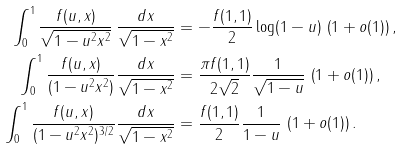Convert formula to latex. <formula><loc_0><loc_0><loc_500><loc_500>\int _ { 0 } ^ { 1 } \frac { f ( u , x ) } { \sqrt { 1 - u ^ { 2 } x ^ { 2 } } } \, \frac { d x } { \sqrt { 1 - x ^ { 2 } } } & = - \frac { f ( 1 , 1 ) } { 2 } \log ( 1 - u ) \, \left ( 1 + o ( 1 ) \right ) , \\ \int _ { 0 } ^ { 1 } \frac { f ( u , x ) } { ( 1 - u ^ { 2 } x ^ { 2 } ) } \frac { d x } { \sqrt { 1 - x ^ { 2 } } } & = \frac { \pi f ( 1 , 1 ) } { 2 \sqrt { 2 } } \frac { 1 } { \sqrt { 1 - u } } \, \left ( 1 + o ( 1 ) \right ) , \\ \int _ { 0 } ^ { 1 } \frac { f ( u , x ) } { ( 1 - u ^ { 2 } x ^ { 2 } ) ^ { 3 / 2 } } \frac { d x } { \sqrt { 1 - x ^ { 2 } } } & = \frac { f ( 1 , 1 ) } { 2 } \frac { 1 } { 1 - u } \, \left ( 1 + o ( 1 ) \right ) .</formula> 